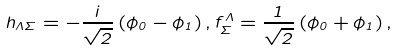Convert formula to latex. <formula><loc_0><loc_0><loc_500><loc_500>h _ { \Lambda \Sigma } = - \frac { i } { \sqrt { 2 } } \left ( \phi _ { 0 } - \phi _ { 1 } \right ) , f _ { \Sigma } ^ { \Lambda } = \frac { 1 } { \sqrt { 2 } } \left ( \phi _ { 0 } + \phi _ { 1 } \right ) ,</formula> 